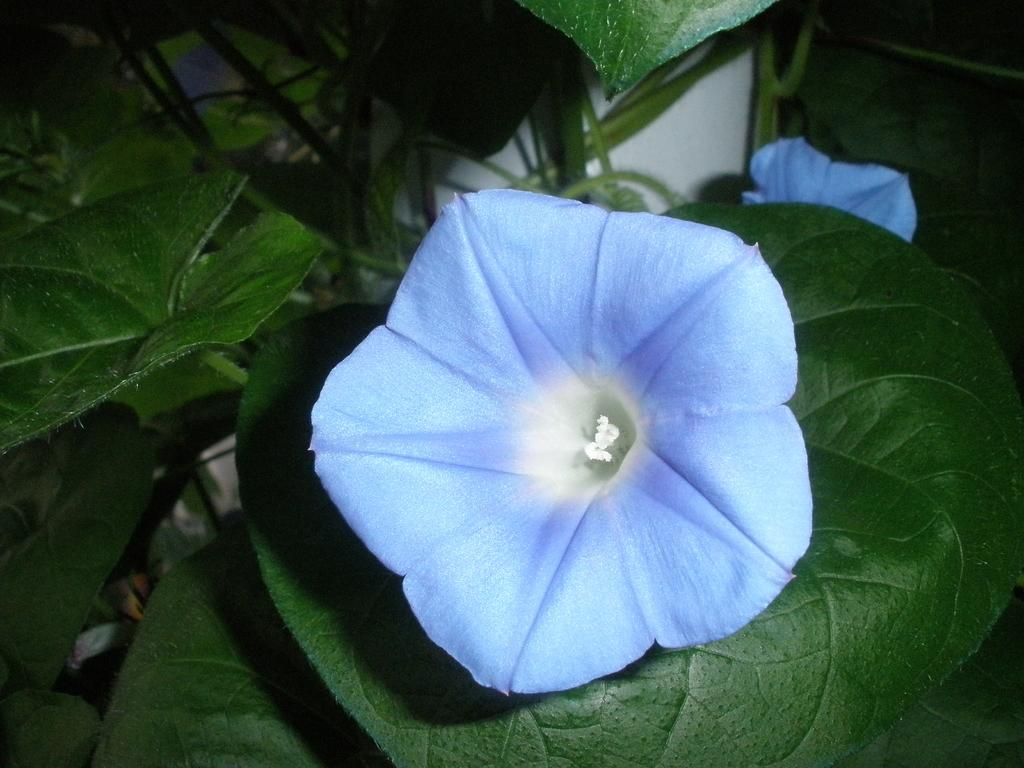What is present in the picture? There is a plant in the picture. Can you describe the plant? The plant has leaves. Is there anything special about one of the leaves? Yes, there is a flower on one of the leaves. What color is the flower? The flower is purple in color. How many pigs are visible in the picture? There are no pigs present in the picture; it features a plant with a purple flower on one of its leaves. Can you describe the steam coming from the plant? There is no steam present in the picture; it is a still image of a plant with a flower. 